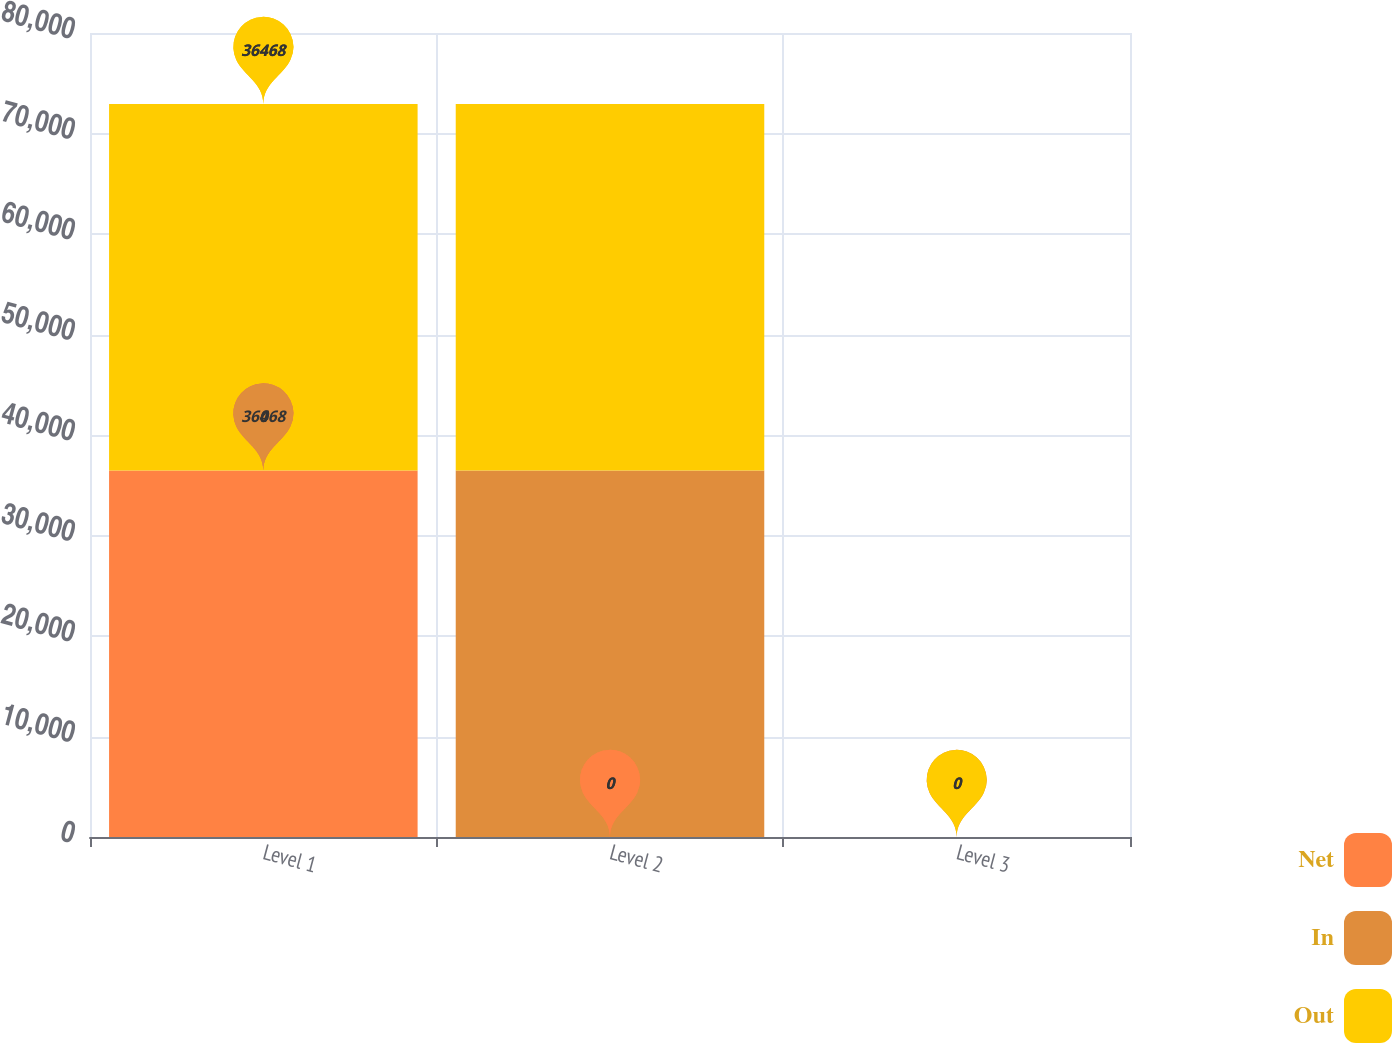Convert chart. <chart><loc_0><loc_0><loc_500><loc_500><stacked_bar_chart><ecel><fcel>Level 1<fcel>Level 2<fcel>Level 3<nl><fcel>Net<fcel>36468<fcel>0<fcel>0<nl><fcel>In<fcel>0<fcel>36468<fcel>0<nl><fcel>Out<fcel>36468<fcel>36468<fcel>0<nl></chart> 